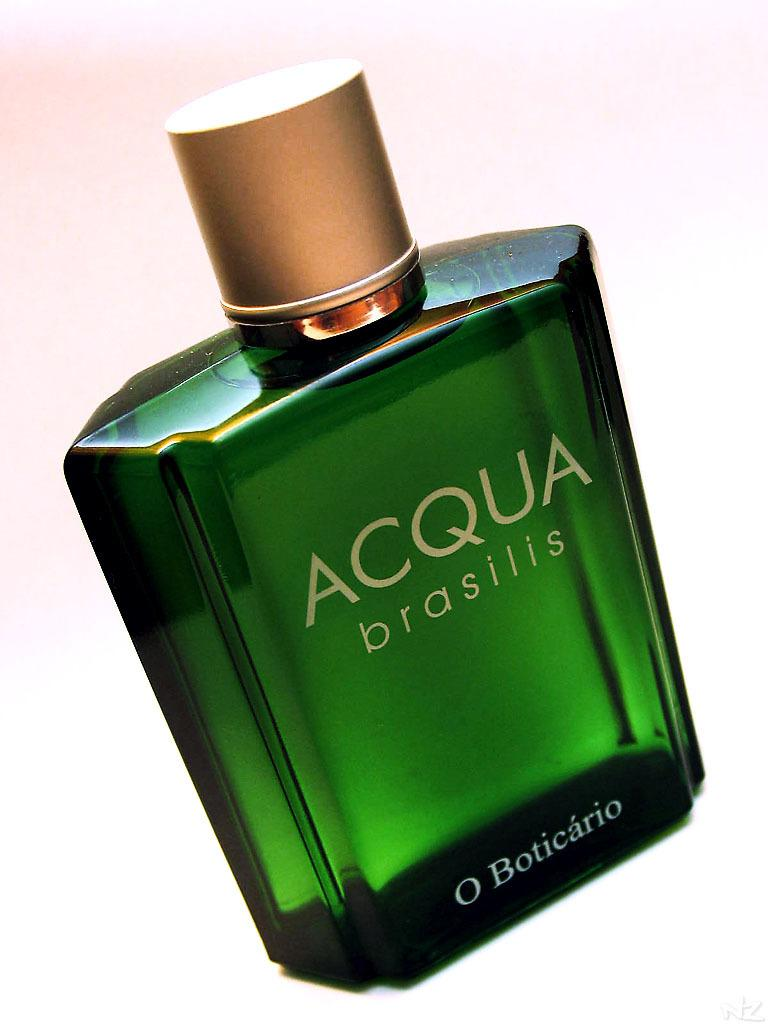<image>
Create a compact narrative representing the image presented. Green bottle of Acqua Brasilis with a gold cap. 